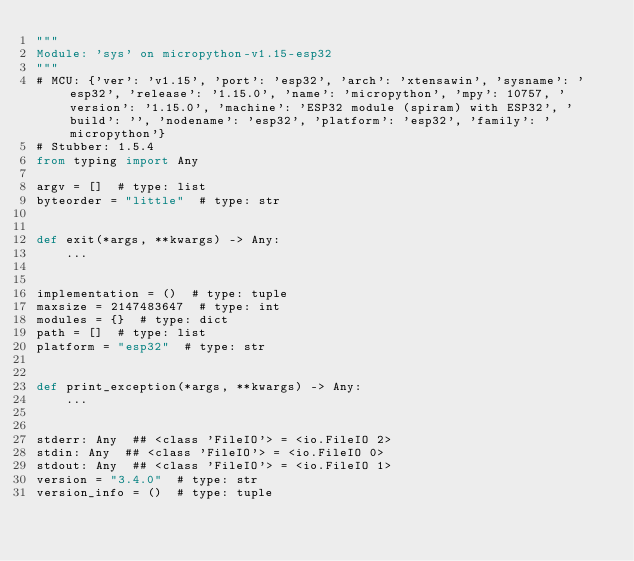Convert code to text. <code><loc_0><loc_0><loc_500><loc_500><_Python_>"""
Module: 'sys' on micropython-v1.15-esp32
"""
# MCU: {'ver': 'v1.15', 'port': 'esp32', 'arch': 'xtensawin', 'sysname': 'esp32', 'release': '1.15.0', 'name': 'micropython', 'mpy': 10757, 'version': '1.15.0', 'machine': 'ESP32 module (spiram) with ESP32', 'build': '', 'nodename': 'esp32', 'platform': 'esp32', 'family': 'micropython'}
# Stubber: 1.5.4
from typing import Any

argv = []  # type: list
byteorder = "little"  # type: str


def exit(*args, **kwargs) -> Any:
    ...


implementation = ()  # type: tuple
maxsize = 2147483647  # type: int
modules = {}  # type: dict
path = []  # type: list
platform = "esp32"  # type: str


def print_exception(*args, **kwargs) -> Any:
    ...


stderr: Any  ## <class 'FileIO'> = <io.FileIO 2>
stdin: Any  ## <class 'FileIO'> = <io.FileIO 0>
stdout: Any  ## <class 'FileIO'> = <io.FileIO 1>
version = "3.4.0"  # type: str
version_info = ()  # type: tuple
</code> 